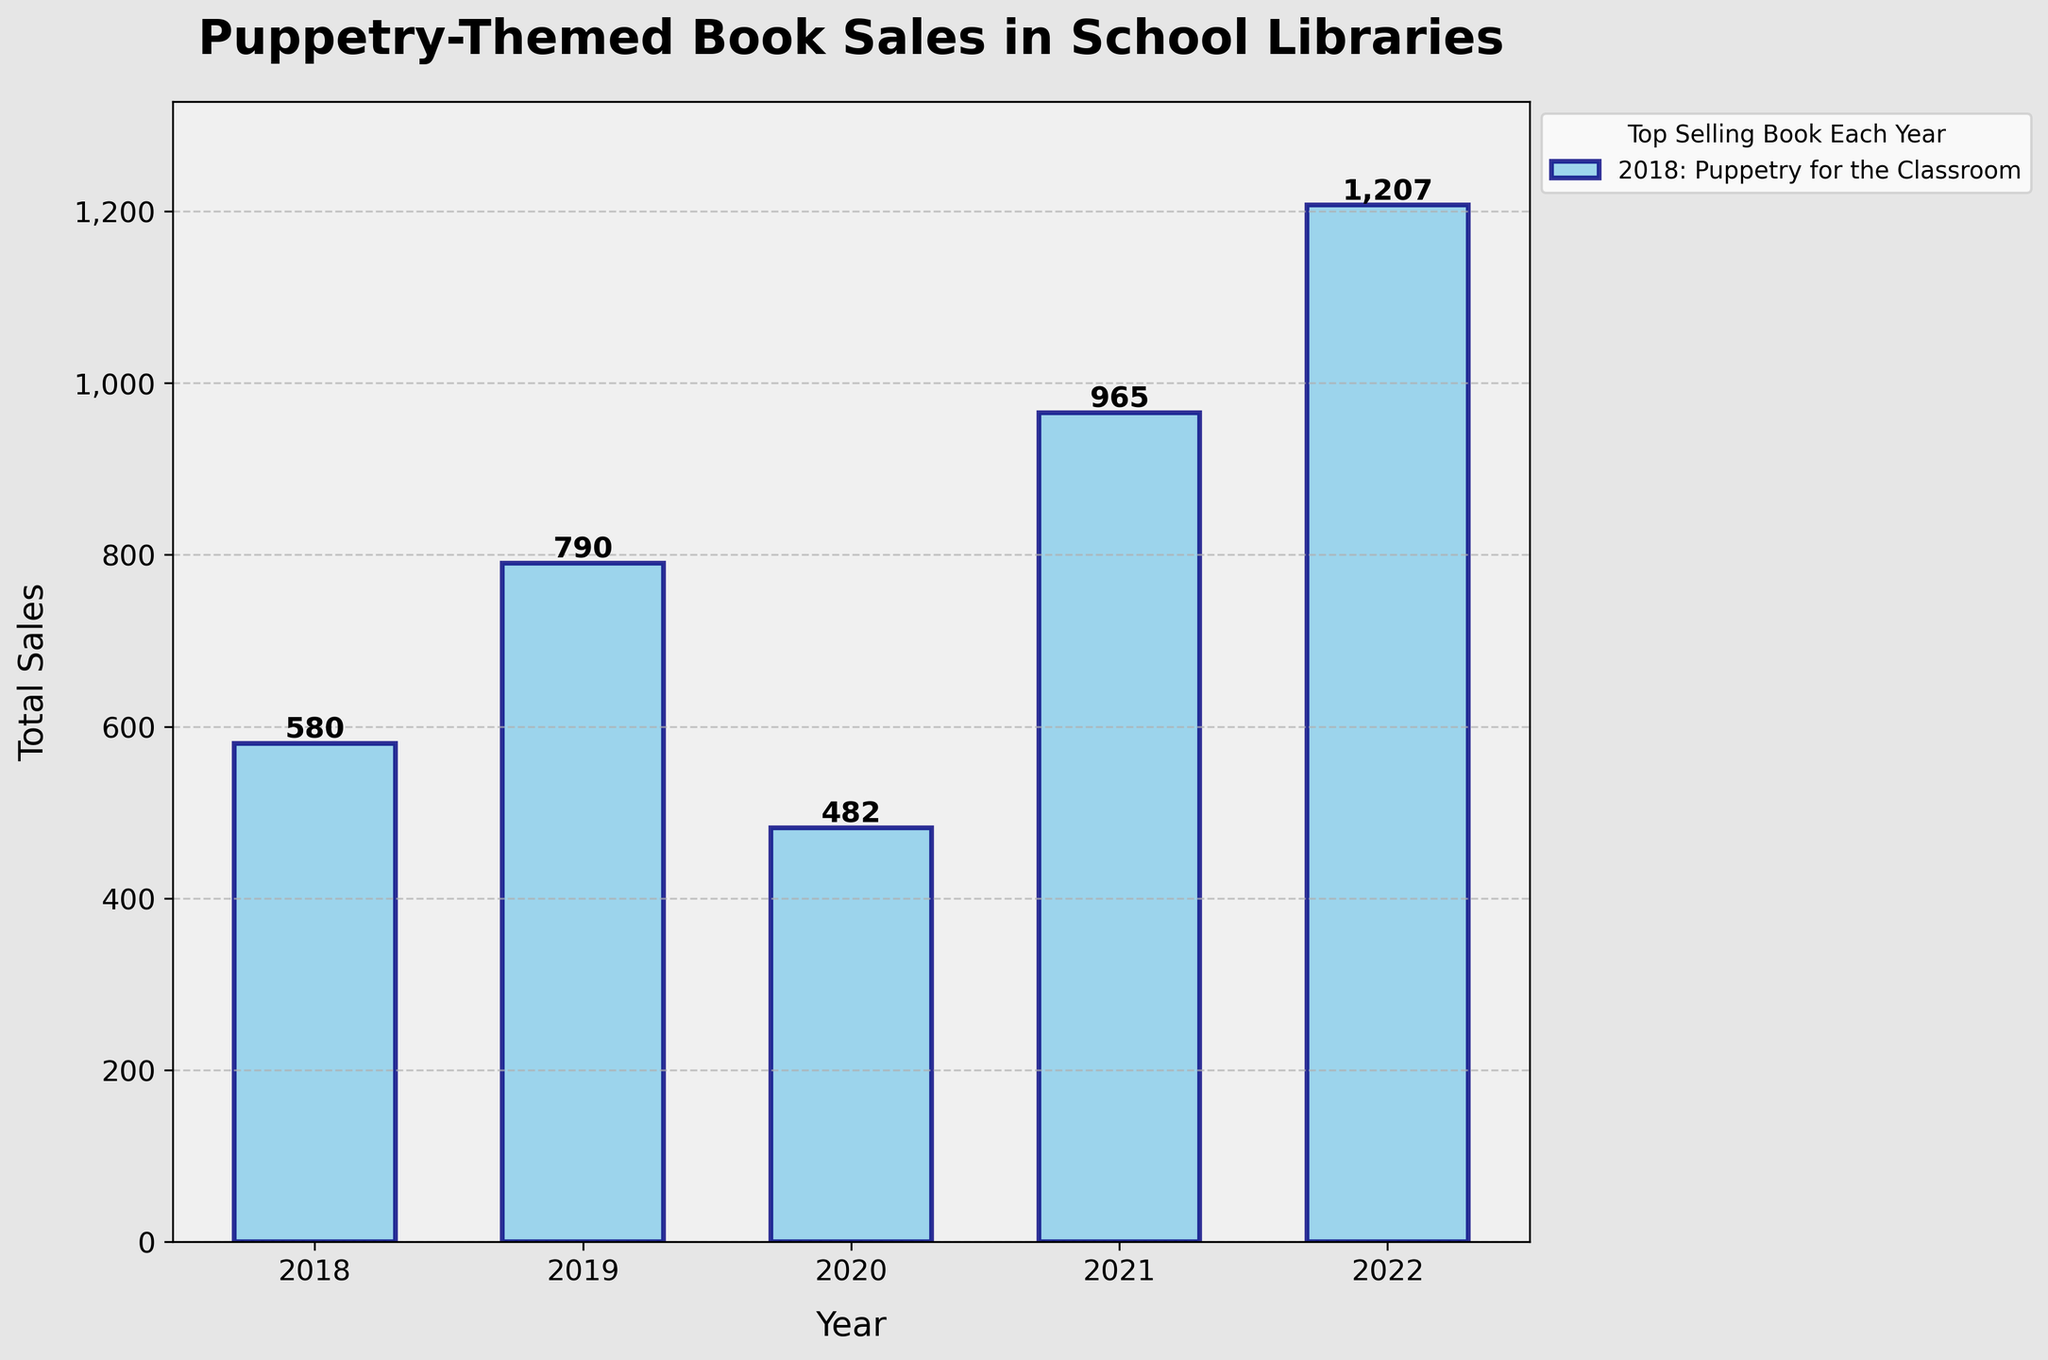What's the total sales for the year 2022? Look at the bar representing the year 2022 and read the value labeled on top of the bar.
Answer: 1207 Which year had the highest sales of puppetry-themed books? Identify the tallest bar in the chart, which visually represents the highest sales.
Answer: 2022 How do the sales figures in 2021 and 2019 compare? Compare the heights of the bars corresponding to the years 2021 and 2019.
Answer: 2021 > 2019 Which year had the lowest sales? Identify the shortest bar in the chart, which visually represents the lowest sales.
Answer: 2020 What is the difference in sales between the highest and lowest year? Find the highest and lowest sales values from the chart and calculate the difference: 1207 (2022) - 482 (2020).
Answer: 725 What's the average sales over the five years? Sum all the sales values (324 + 412 + 287 + 503 + 618 + 256 + 378 + 195 + 462 + 589) and divide by the number of years (5).
Answer: 813.4 Are there any years where the total sales exceed 1000 units? Look for bars with values labeled higher than 1000.
Answer: Yes, 2022 What are the titles of the top selling books for the year 2020? Refer to the legend on the side and identify the title listed for 2020.
Answer: Shadow Puppets Around the World How much did the sales increase from 2018 to 2022? Subtract the 2018 sales (580) from the 2022 sales (1207).
Answer: 627 Which year saw the highest increase in sales compared to the previous year? Calculate the year-over-year sales difference and identify the highest increase: 2019 - 2018, 2020 - 2019, 2021 - 2020, 2022 - 2021.
Answer: 2022 